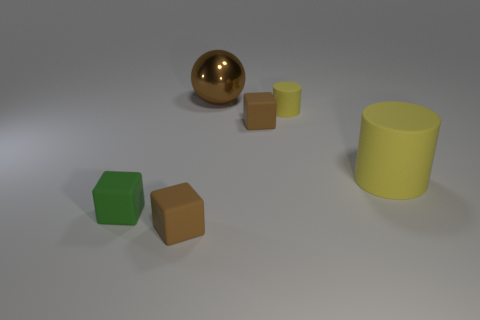Is the size of the green rubber cube the same as the brown shiny thing behind the green matte object?
Offer a terse response. No. Is there any other thing that has the same material as the large brown sphere?
Provide a short and direct response. No. Are there fewer brown spheres that are to the left of the tiny green matte thing than small blocks that are on the left side of the big matte thing?
Your response must be concise. Yes. The rubber thing that is right of the green rubber object and in front of the big yellow matte thing has what shape?
Offer a terse response. Cube. How many large yellow objects are the same shape as the small green matte thing?
Your answer should be very brief. 0. There is a yellow thing that is the same material as the small yellow cylinder; what is its size?
Ensure brevity in your answer.  Large. What number of yellow matte objects are the same size as the green block?
Offer a terse response. 1. The object that is the same color as the tiny rubber cylinder is what size?
Provide a short and direct response. Large. What color is the tiny cube to the left of the rubber thing in front of the green matte thing?
Provide a succinct answer. Green. Is there a big object of the same color as the tiny cylinder?
Provide a short and direct response. Yes. 